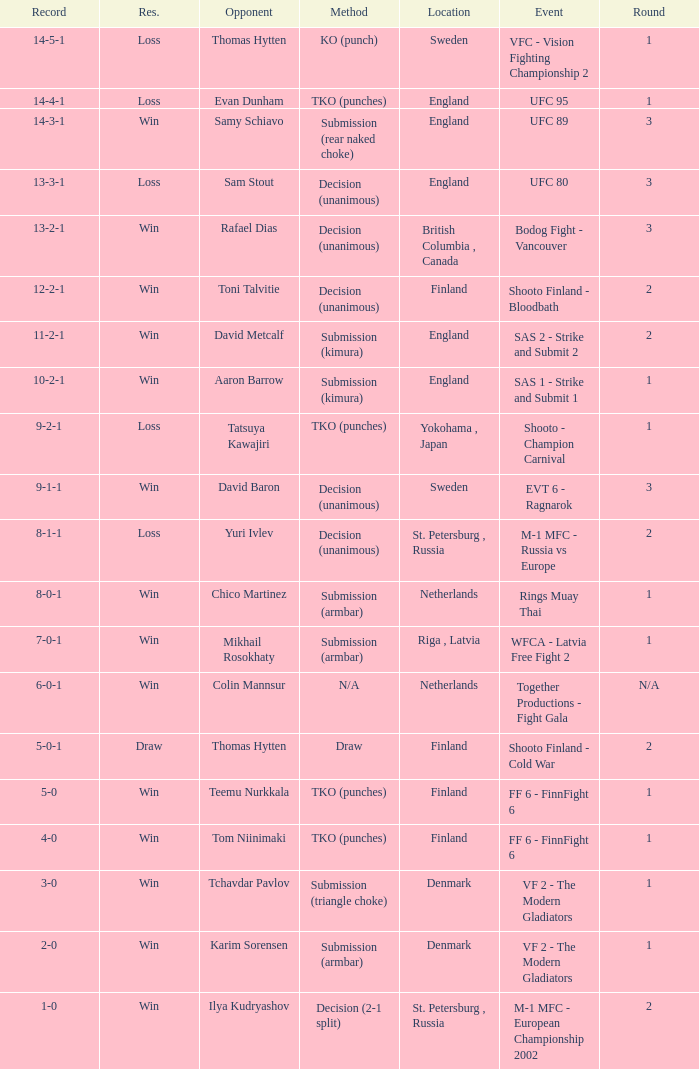What's the location when the record was 6-0-1? Netherlands. 